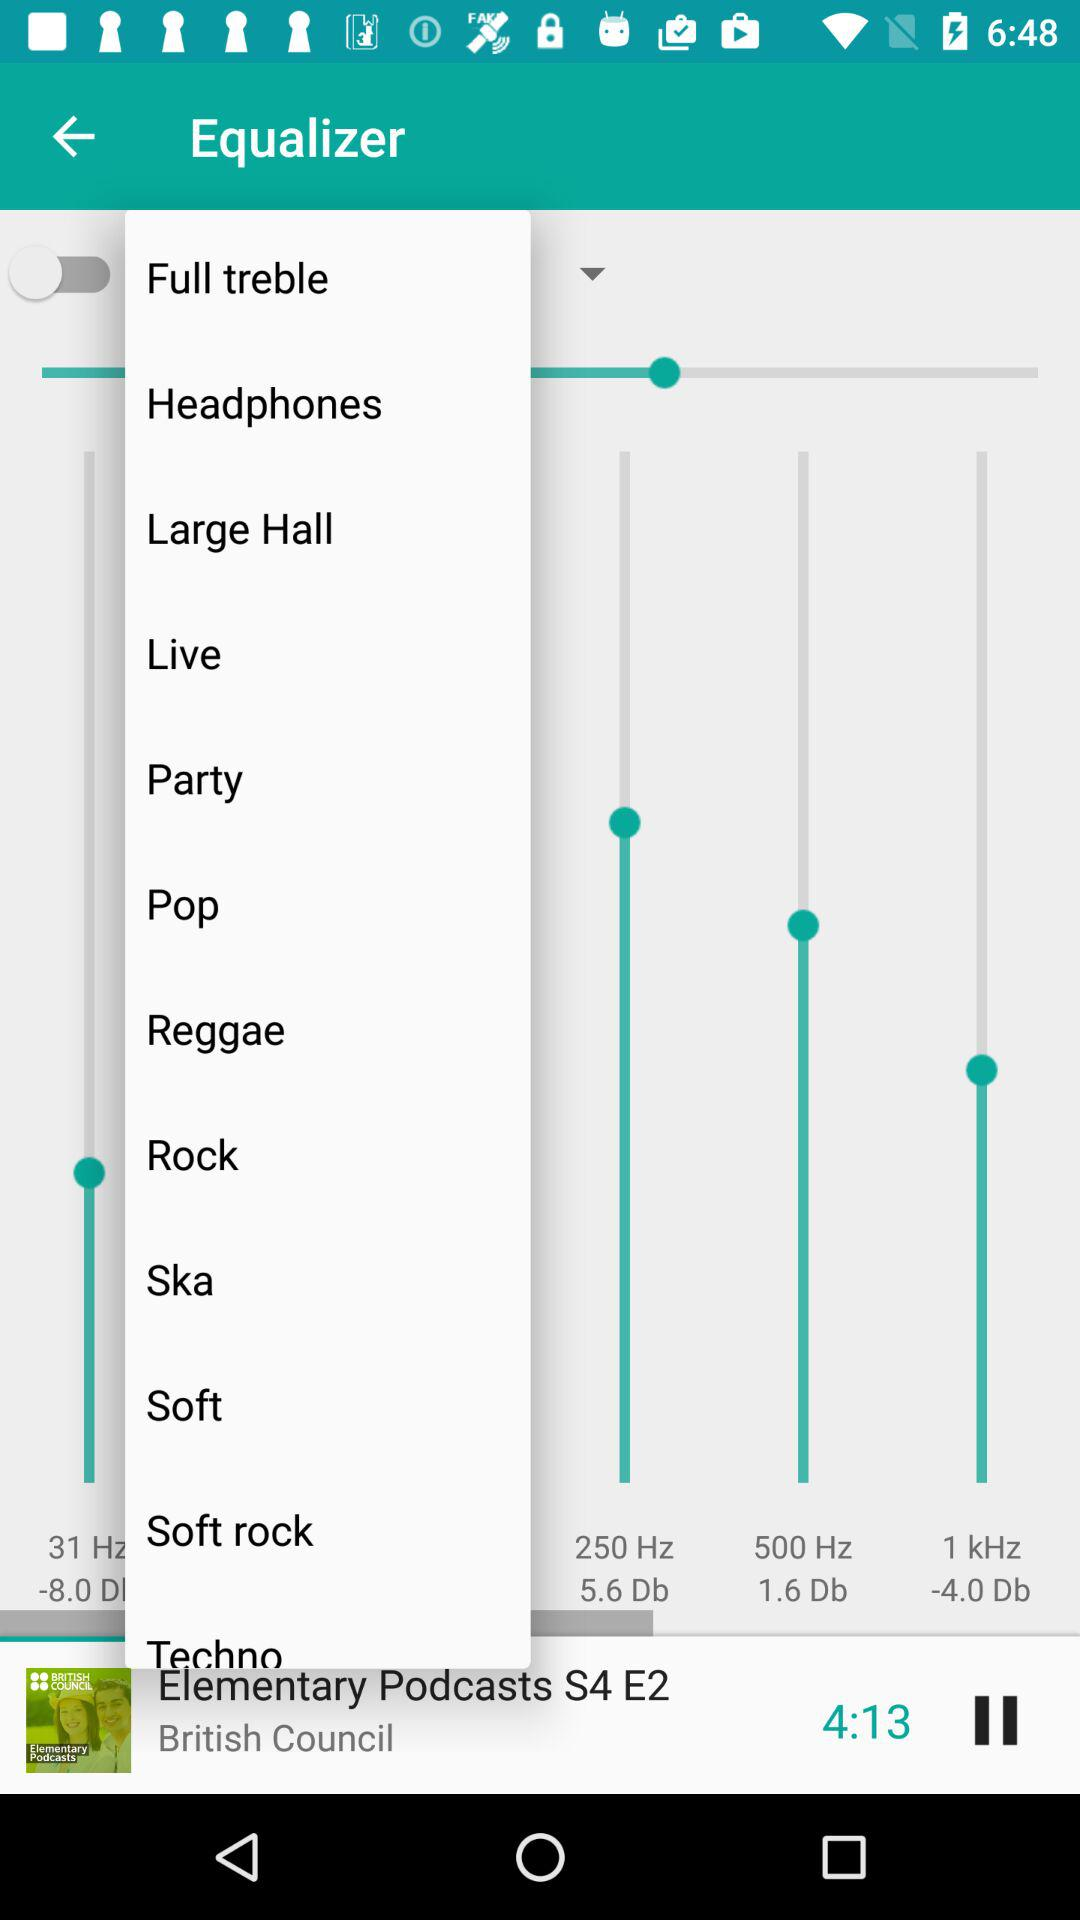Which audio is currently playing? The audio which is currently playing is Elementary Podcasts S4 E2. 